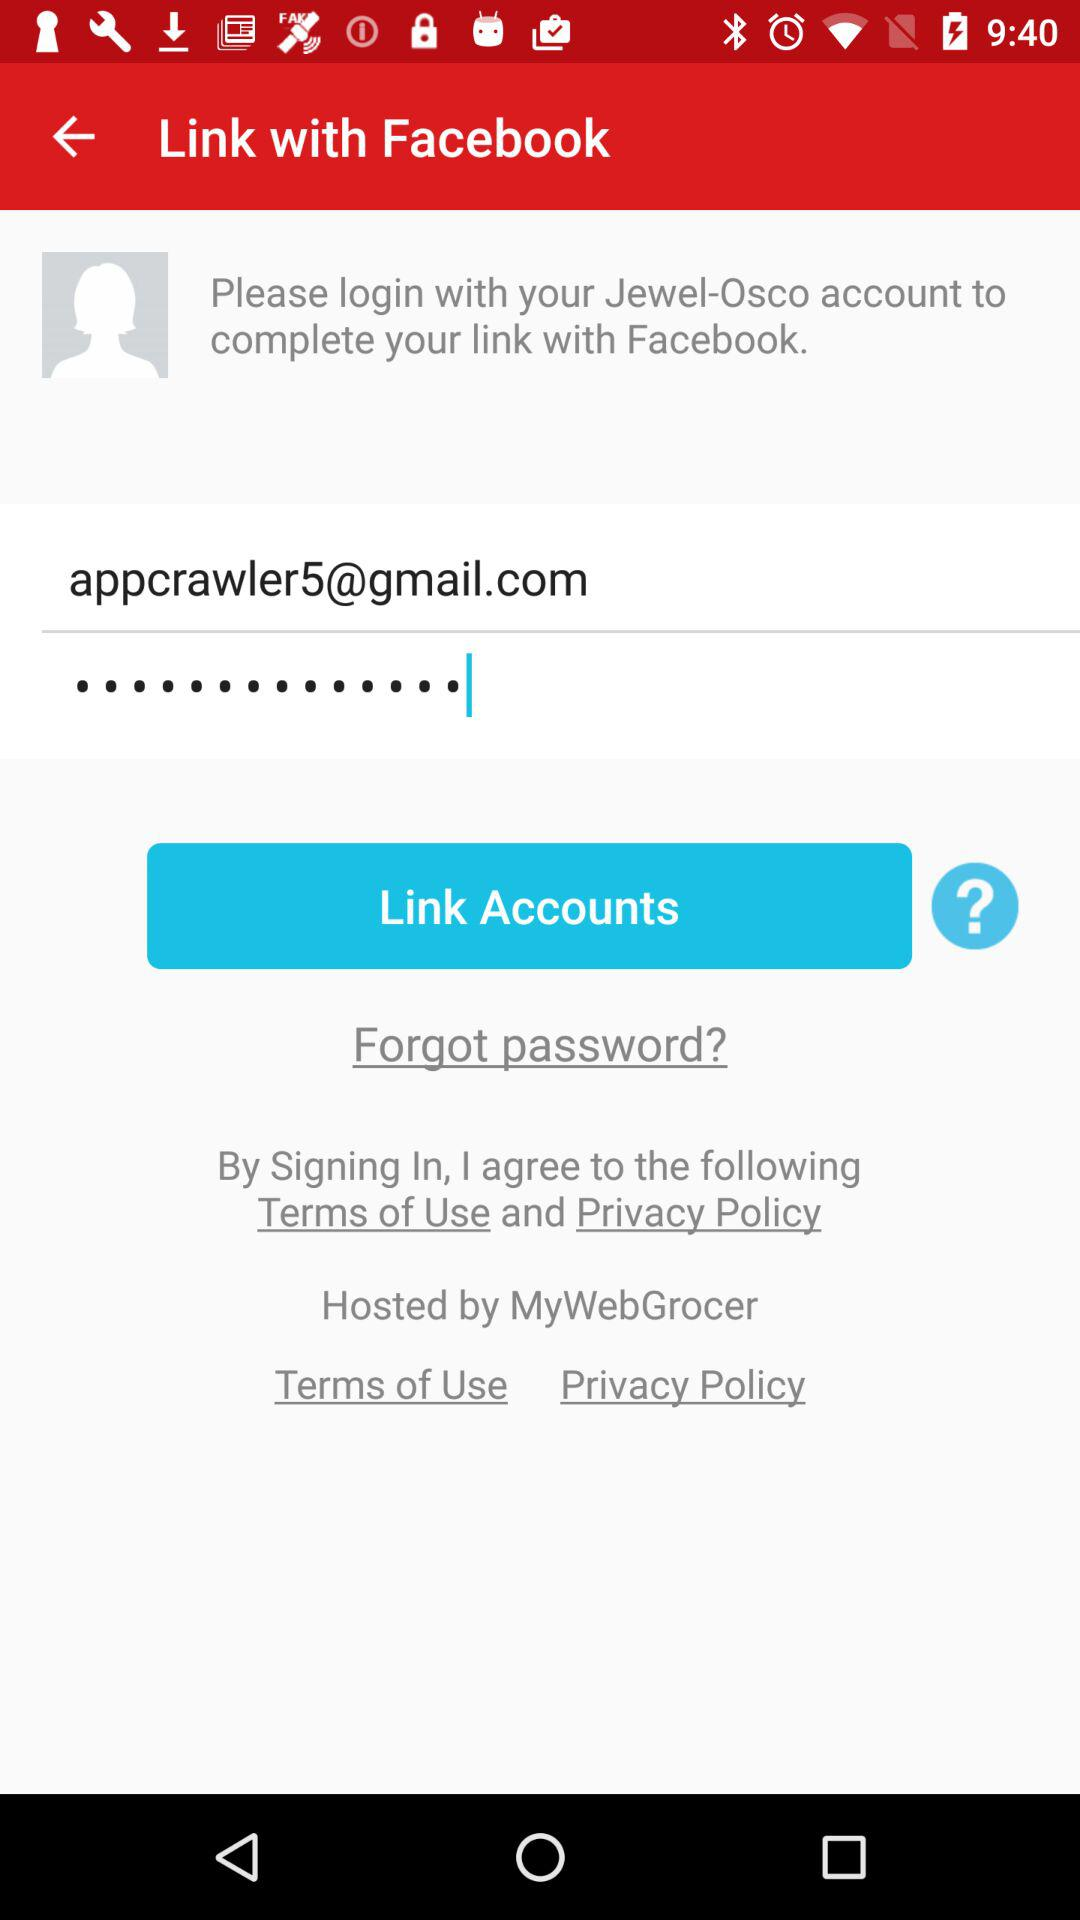What account does the user have to log in with to complete the link with "Facebook"? The user has to log in with the "Jewel-Osco" account to complete the link with "Facebook". 